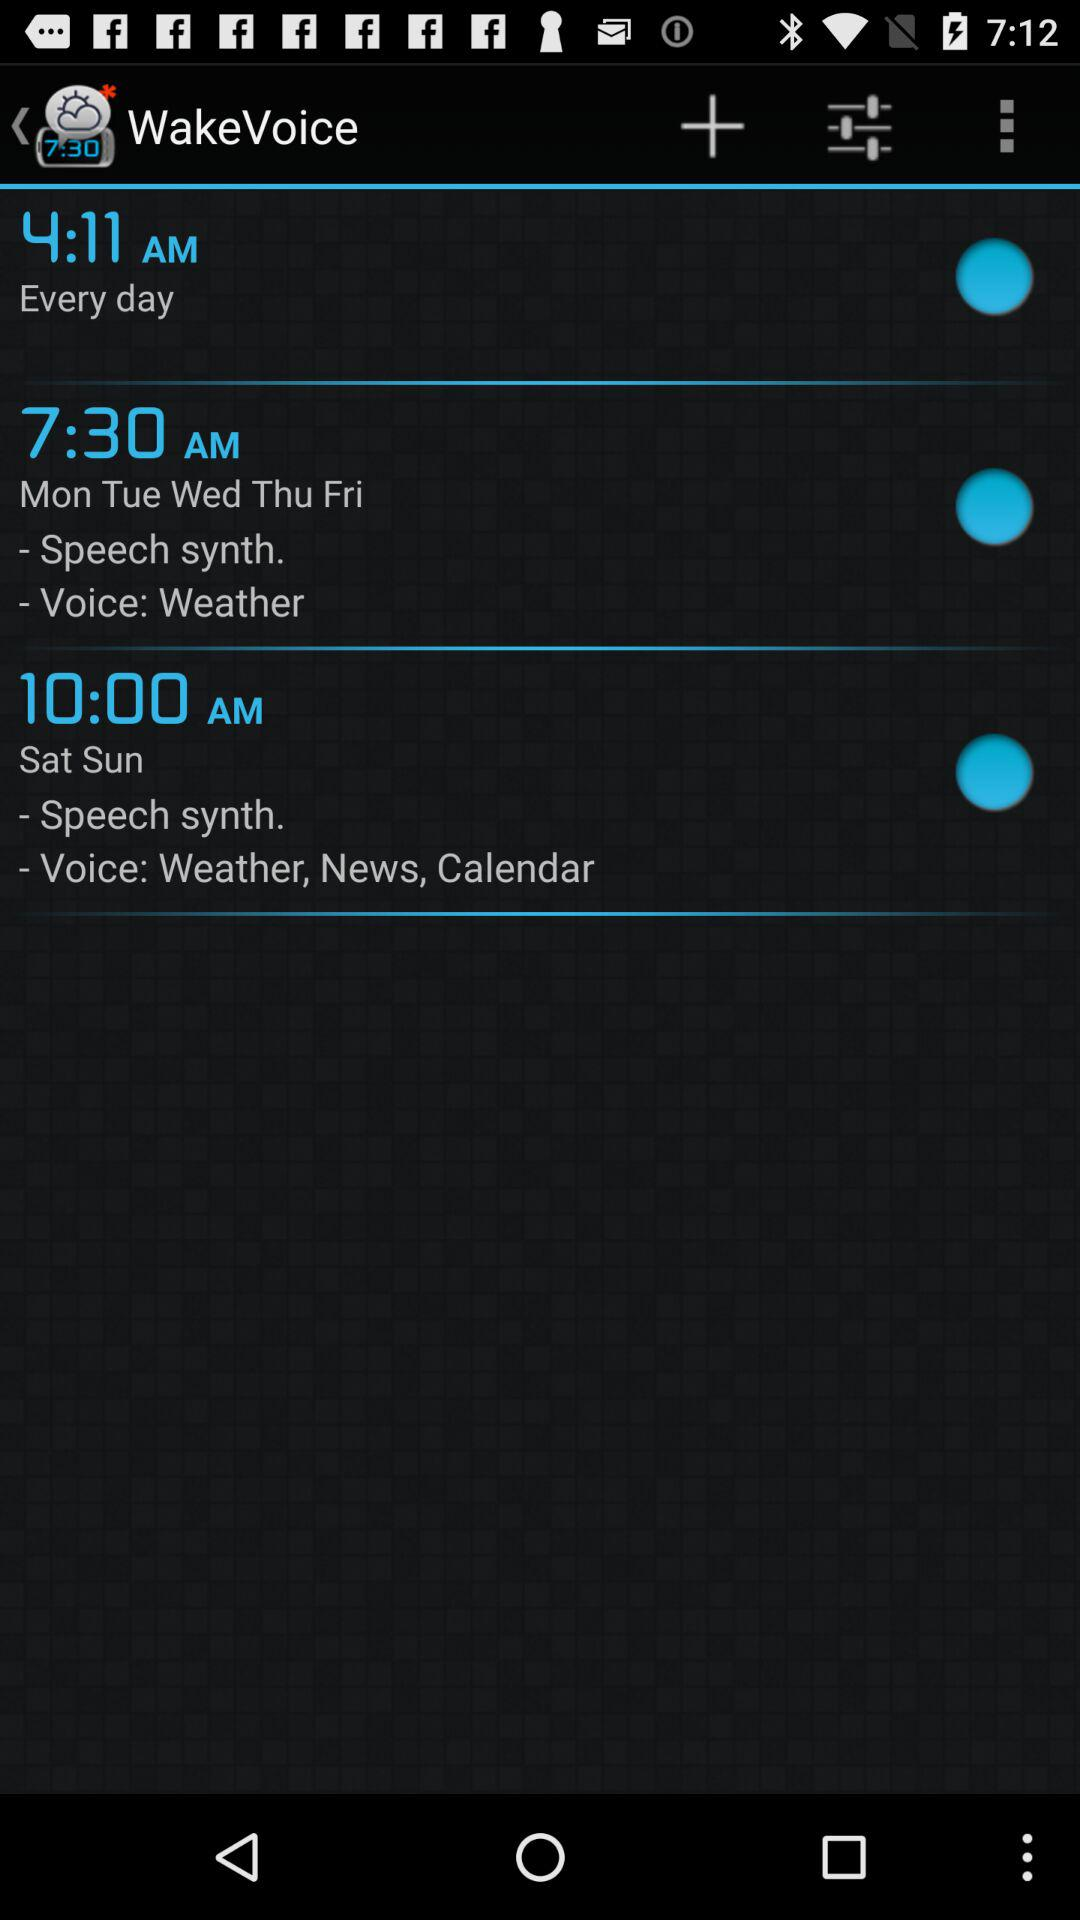What is the name of the voice that is set for Saturday and Sunday? The names of the voices are Weather, News and Calendar. 